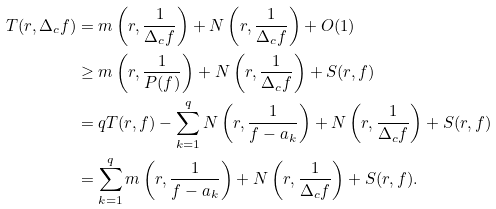<formula> <loc_0><loc_0><loc_500><loc_500>T ( r , \Delta _ { c } f ) & = m \left ( r , \frac { 1 } { \Delta _ { c } f } \right ) + N \left ( r , \frac { 1 } { \Delta _ { c } f } \right ) + O ( 1 ) \\ & \geq m \left ( r , \frac { 1 } { P ( f ) } \right ) + N \left ( r , \frac { 1 } { \Delta _ { c } f } \right ) + S ( r , f ) \\ & = q T ( r , f ) - \sum _ { k = 1 } ^ { q } N \left ( r , \frac { 1 } { f - a _ { k } } \right ) + N \left ( r , \frac { 1 } { \Delta _ { c } f } \right ) + S ( r , f ) \\ & = \sum _ { k = 1 } ^ { q } m \left ( r , \frac { 1 } { f - a _ { k } } \right ) + N \left ( r , \frac { 1 } { \Delta _ { c } f } \right ) + S ( r , f ) . \\</formula> 